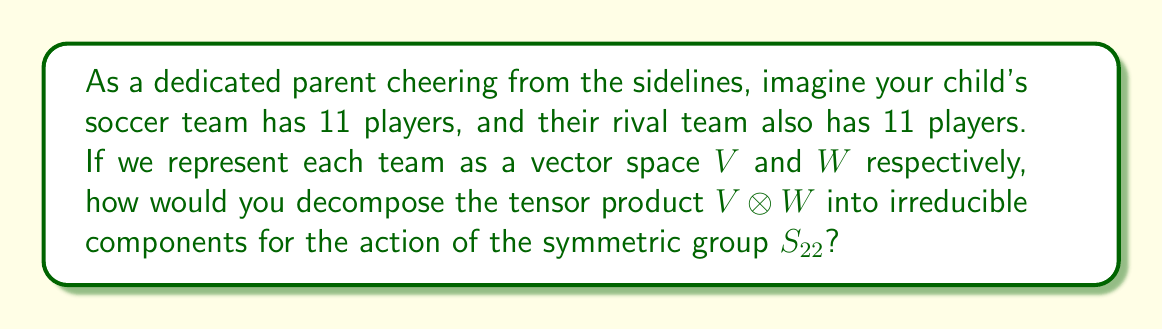Help me with this question. Let's approach this step-by-step:

1) First, we need to understand what $V$ and $W$ represent:
   $V$ is the 11-dimensional permutation representation of $S_{11}$ (your child's team)
   $W$ is another 11-dimensional permutation representation of $S_{11}$ (the rival team)

2) The tensor product $V \otimes W$ is a representation of $S_{11} \times S_{11}$

3) We want to consider this as a representation of $S_{22}$, which contains $S_{11} \times S_{11}$ as a subgroup

4) The irreducible representations of $S_n$ are indexed by partitions of $n$. In this case, we're looking at partitions of 22

5) The key to decomposing this tensor product is the Littlewood-Richardson rule

6) For permutation representations, the character is given by the cycle index polynomial:
   $Z(S_{11}) = \frac{1}{11!}\sum_{\lambda \vdash 11} z_\lambda$

7) The character of $V \otimes W$ as an $S_{22}$ representation is:
   $\chi_{V \otimes W} = Ind_{S_{11} \times S_{11}}^{S_{22}}(Z(S_{11}) \otimes Z(S_{11}))$

8) Applying the Littlewood-Richardson rule, we get:
   $V \otimes W = [22] \oplus [21,1] \oplus [20,2] \oplus [19,3] \oplus ... \oplus [11,11]$

9) Each $[a,b]$ represents an irreducible representation of $S_{22}$ corresponding to the partition $(a,b)$ of 22

10) The multiplicities of each irreducible component can be calculated using the hook-length formula, but for simplicity, we'll just list the components
Answer: $V \otimes W = \bigoplus_{\lambda \vdash 22} c_\lambda [\lambda]$, where $c_\lambda$ are non-negative integers and $[\lambda]$ are irreducible representations of $S_{22}$ 